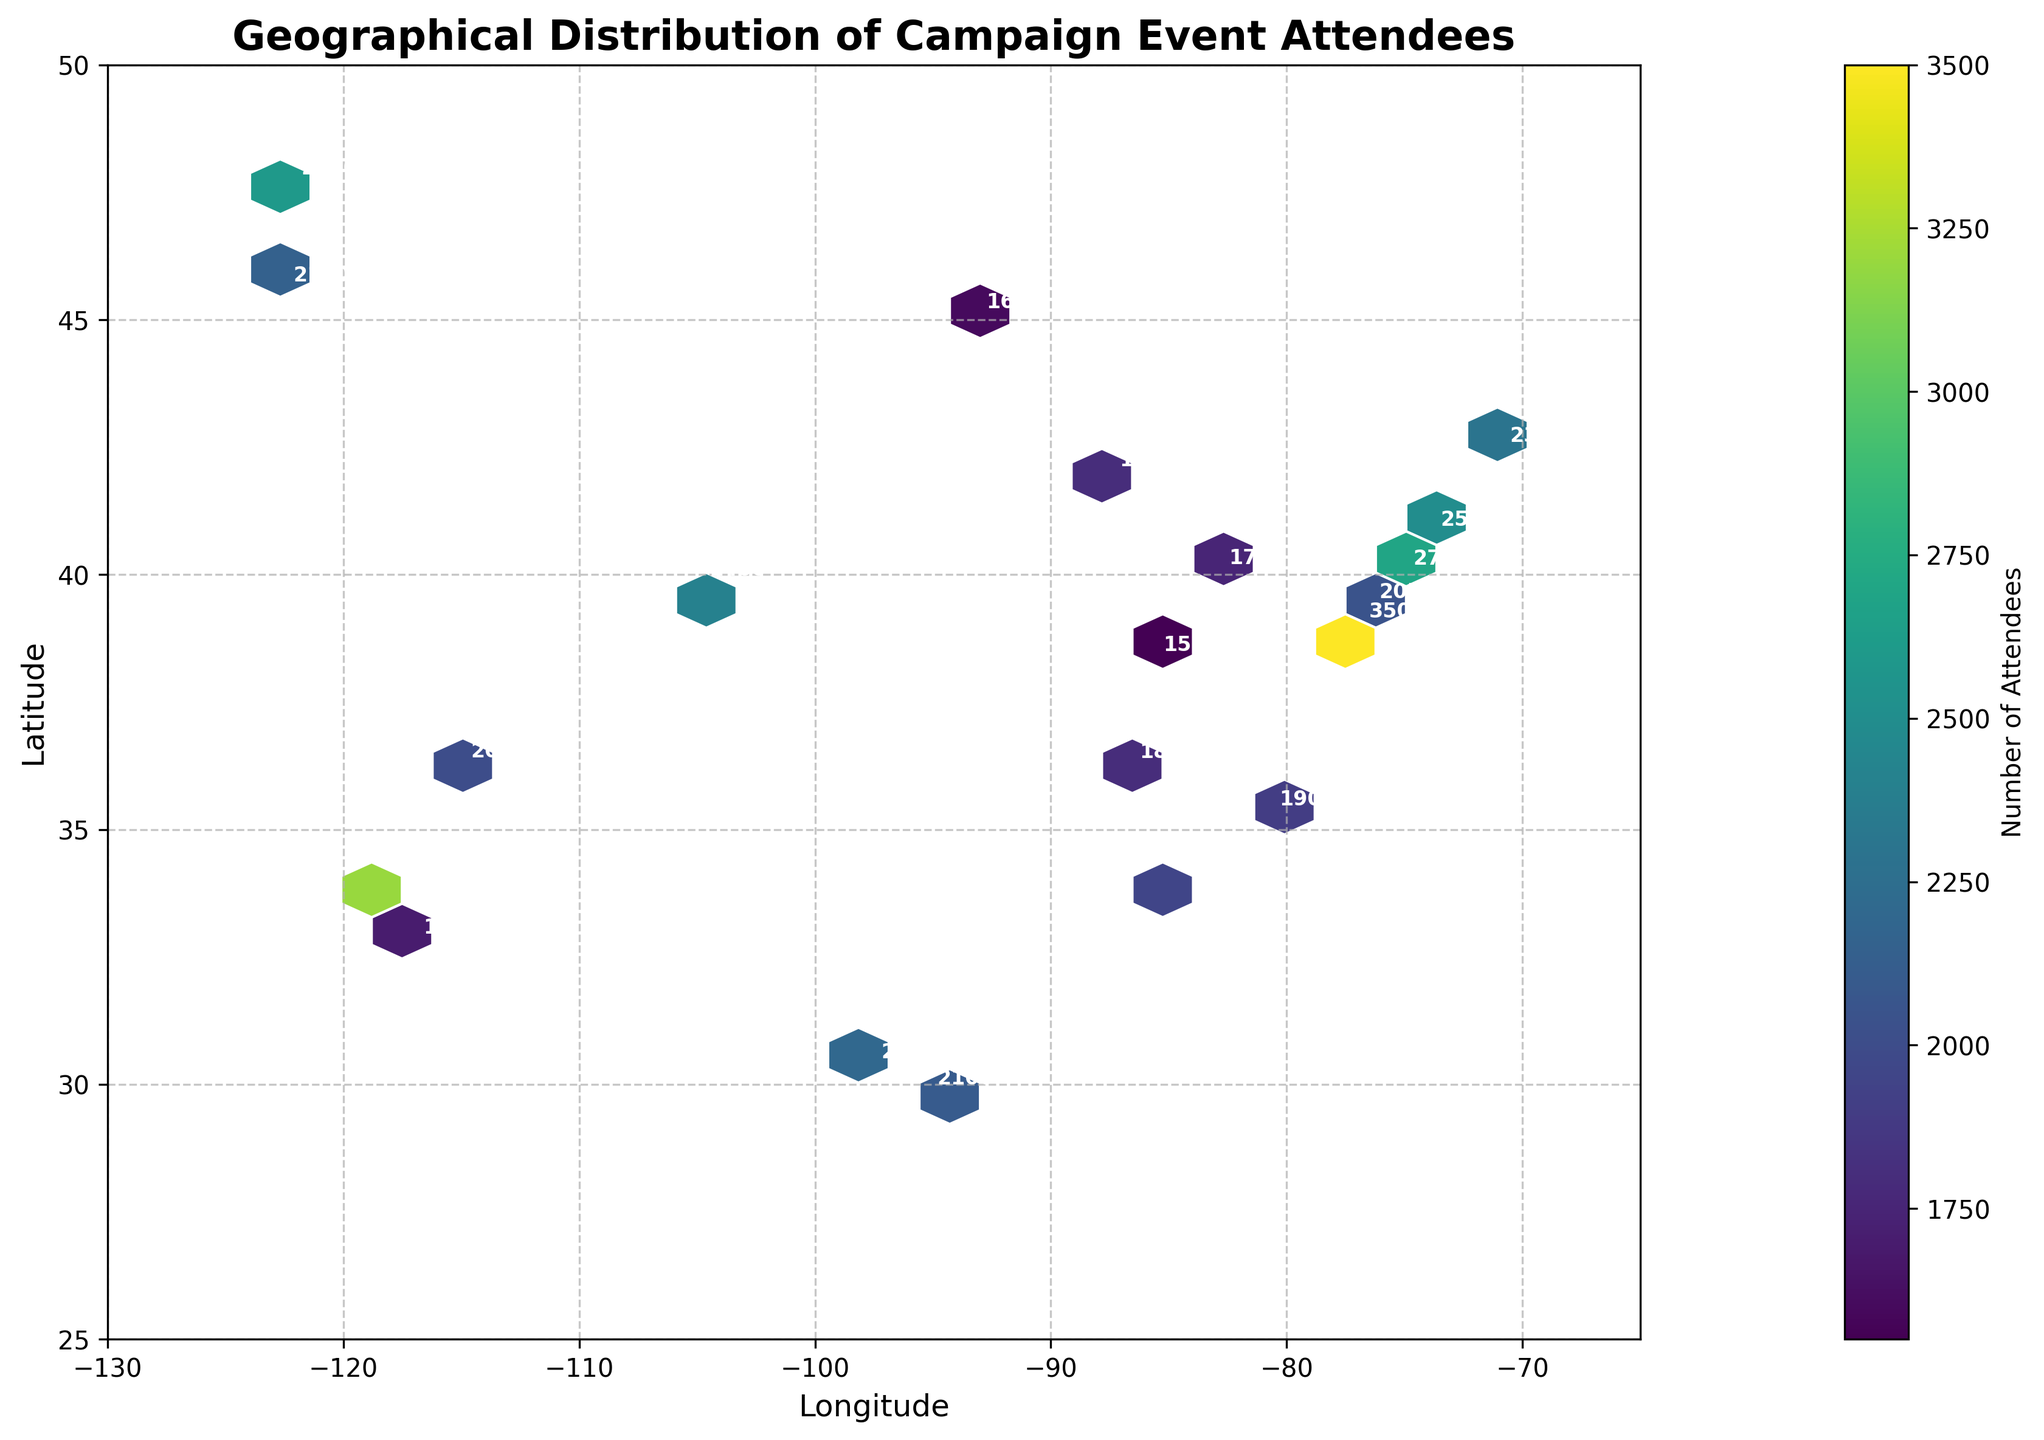How many data points are plotted in the hexbin plot? The hexbin plot annotates each point with the number of attendees at that location. By counting these annotations, we can determine the number of data points in the plot.
Answer: 20 What does the color intensity in the hexbin plot signify? The color intensity in hexbin plots represents the concentration of data points within the hexagons. In this plot, color intensity shows the number of attendees, with darker colors indicating higher numbers.
Answer: Number of attendees What is the title of the hexbin plot? Look at the top section of the plot where the title is usually placed.
Answer: Geographical Distribution of Campaign Event Attendees Which location has the highest number of attendees and what is that number? From the annotations on individual points in the hexbin plot, find the location with the largest attendee number.
Answer: Washington, D.C., 3500 Are there more attendees on the East Coast or West Coast of the United States, according to the plot? Sum the number of attendees for cities on the East Coast (e.g., New York, Philadelphia, Boston) and compare it to the sum for West Coast cities (e.g., Los Angeles, San Diego, Seattle).
Answer: West Coast How does the number of attendees in Chicago compare to that in Houston? Refer to the annotated numbers for Chicago (latitude: 41.8781, longitude: -87.6298) and Houston (latitude: 29.7604, longitude: -95.3698). Compare these two numbers.
Answer: Houston has more attendees (2100 vs 1800) What are the grid size and color scheme used in the hexbin plot? Examine the visual properties of the hexbin plot to determine the grid size and color scheme (cmap).
Answer: Grid size: 20, Color scheme: Viridis What is the colorbar label in the hexbin plot? Check the colorbar, usually positioned on one side of the plot, and read its label.
Answer: Number of Attendees Which cities have fewer than 2000 attendees? Identify annotations in the hexbin plot that have numbers less than 2000. These are the cities: Chicago, San Diego, Las Vegas, Minneapolis, Columbus, Louisville, Nashville.
Answer: Chicago, San Diego, Las Vegas, Minneapolis, Columbus, Louisville, Nashville What's the range of latitudes and longitudes in the hexbin plot? Review the x-axis and y-axis labels to find the minimum and maximum values for latitude and longitude covered in the plot.
Answer: Longitude: -130 to -65, Latitude: 25 to 50 